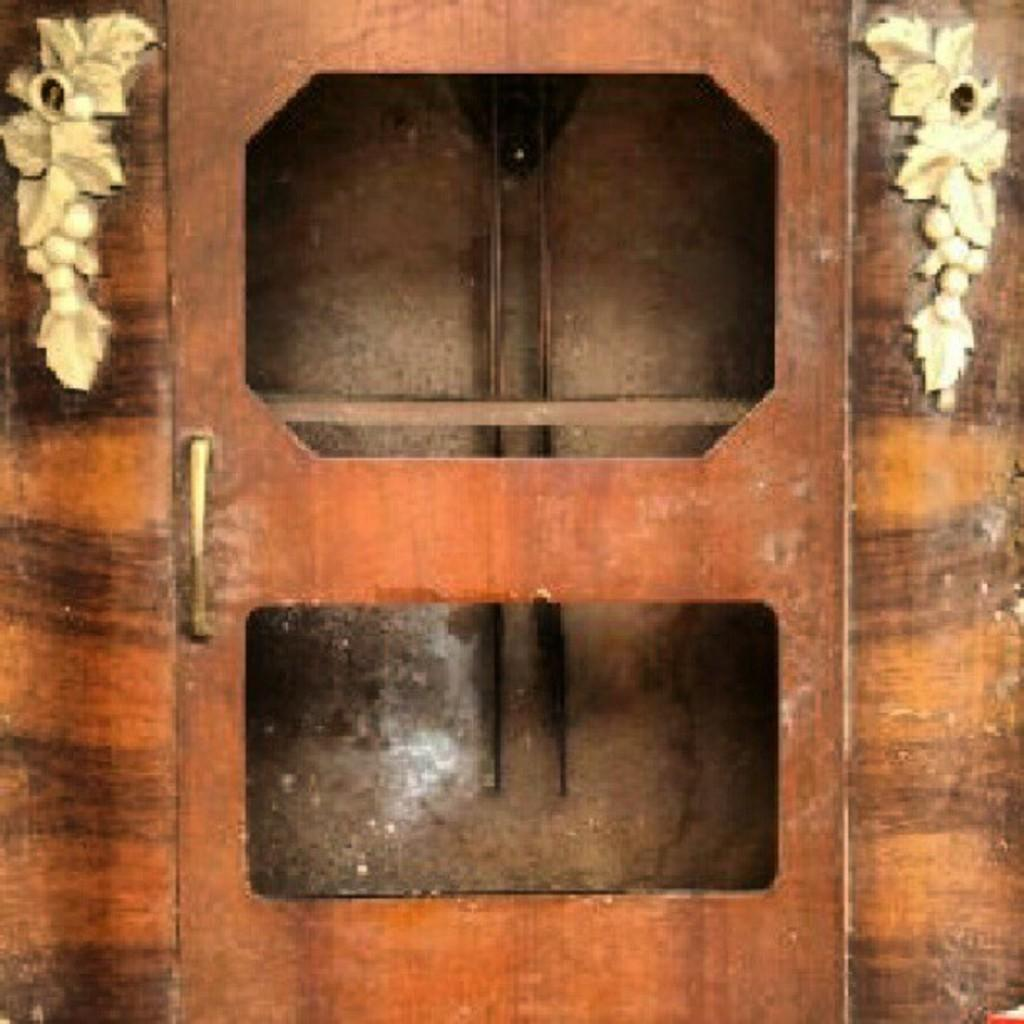What can be found on the door in the image? There is a door handle on the door in the image. What is the color of the door? The door is brown in color. What is the color of the wall surrounding the door? There is a brown wall in the image. What design is present on either side of the door? There is a design in white color on either side of the door. What type of jam is being spread on the chalk in the image? There is no jam or chalk present in the image; it only features a door with a door handle, a brown door, a brown wall, and a design in white color on either side of the door. 